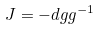<formula> <loc_0><loc_0><loc_500><loc_500>J = - d g g ^ { - 1 }</formula> 